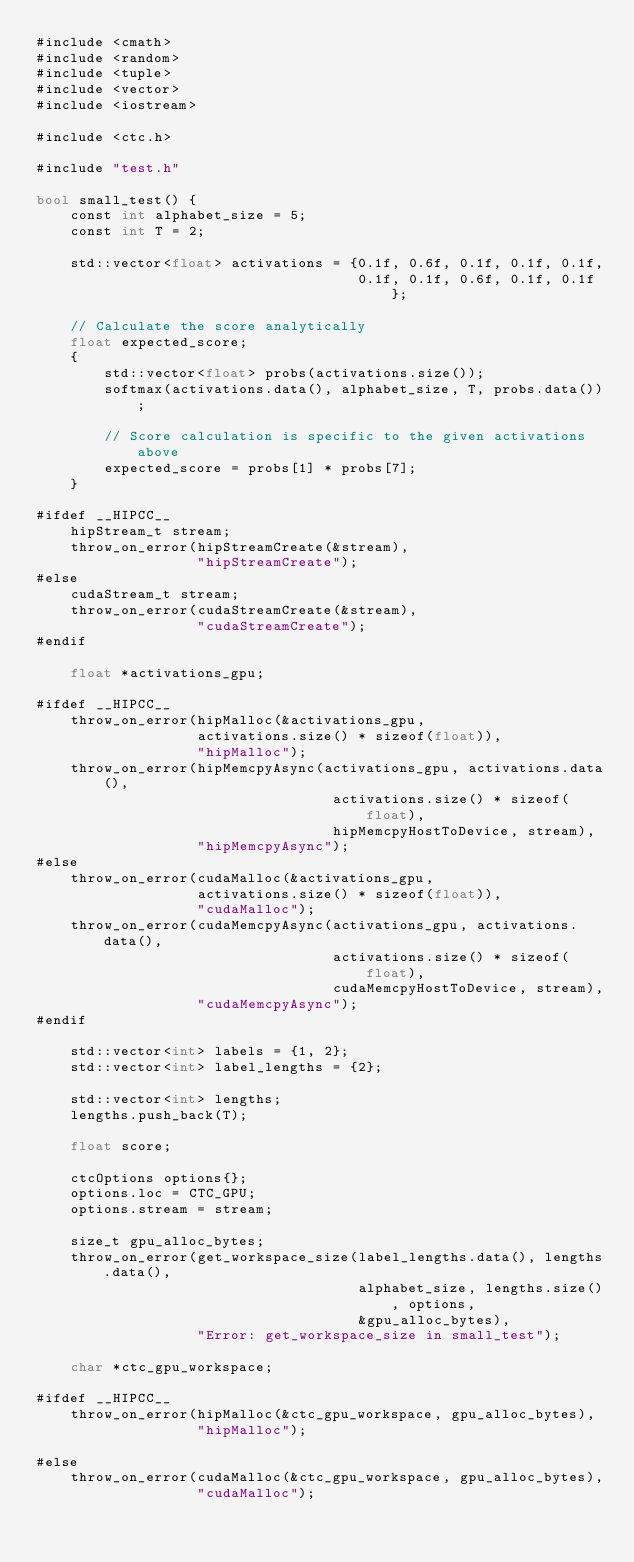<code> <loc_0><loc_0><loc_500><loc_500><_Cuda_>#include <cmath>
#include <random>
#include <tuple>
#include <vector>
#include <iostream>

#include <ctc.h>

#include "test.h"

bool small_test() {
    const int alphabet_size = 5;
    const int T = 2;

    std::vector<float> activations = {0.1f, 0.6f, 0.1f, 0.1f, 0.1f,
                                      0.1f, 0.1f, 0.6f, 0.1f, 0.1f};

    // Calculate the score analytically
    float expected_score;
    {
        std::vector<float> probs(activations.size());
        softmax(activations.data(), alphabet_size, T, probs.data());

        // Score calculation is specific to the given activations above
        expected_score = probs[1] * probs[7];
    }

#ifdef __HIPCC__
    hipStream_t stream;
    throw_on_error(hipStreamCreate(&stream),
                   "hipStreamCreate");
#else
    cudaStream_t stream;
    throw_on_error(cudaStreamCreate(&stream),
                   "cudaStreamCreate");
#endif

    float *activations_gpu;

#ifdef __HIPCC__
    throw_on_error(hipMalloc(&activations_gpu,
                   activations.size() * sizeof(float)),
                   "hipMalloc");
    throw_on_error(hipMemcpyAsync(activations_gpu, activations.data(),
                                   activations.size() * sizeof(float),
                                   hipMemcpyHostToDevice, stream),
                   "hipMemcpyAsync");
#else
    throw_on_error(cudaMalloc(&activations_gpu,
                   activations.size() * sizeof(float)),
                   "cudaMalloc");
    throw_on_error(cudaMemcpyAsync(activations_gpu, activations.data(),
                                   activations.size() * sizeof(float),
                                   cudaMemcpyHostToDevice, stream),
                   "cudaMemcpyAsync");
#endif

    std::vector<int> labels = {1, 2};
    std::vector<int> label_lengths = {2};

    std::vector<int> lengths;
    lengths.push_back(T);

    float score;

    ctcOptions options{};
    options.loc = CTC_GPU;
    options.stream = stream;

    size_t gpu_alloc_bytes;
    throw_on_error(get_workspace_size(label_lengths.data(), lengths.data(),
                                      alphabet_size, lengths.size(), options,
                                      &gpu_alloc_bytes),
                   "Error: get_workspace_size in small_test");

    char *ctc_gpu_workspace;

#ifdef __HIPCC__
    throw_on_error(hipMalloc(&ctc_gpu_workspace, gpu_alloc_bytes),
                   "hipMalloc");

#else
    throw_on_error(cudaMalloc(&ctc_gpu_workspace, gpu_alloc_bytes),
                   "cudaMalloc");</code> 